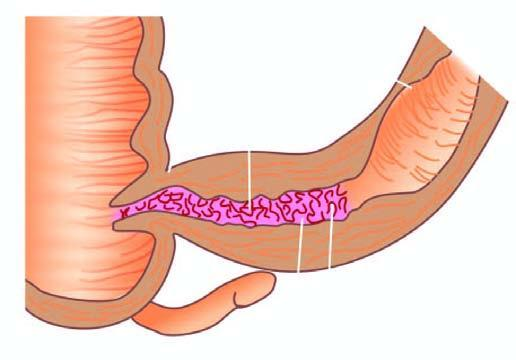does external surface show increased mesenteric fat, thickened wall and narrow lumen?
Answer the question using a single word or phrase. Yes 